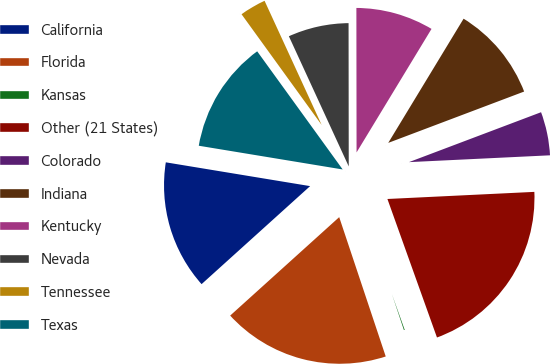Convert chart to OTSL. <chart><loc_0><loc_0><loc_500><loc_500><pie_chart><fcel>California<fcel>Florida<fcel>Kansas<fcel>Other (21 States)<fcel>Colorado<fcel>Indiana<fcel>Kentucky<fcel>Nevada<fcel>Tennessee<fcel>Texas<nl><fcel>14.29%<fcel>18.44%<fcel>0.34%<fcel>20.3%<fcel>4.98%<fcel>10.57%<fcel>8.7%<fcel>6.84%<fcel>3.11%<fcel>12.43%<nl></chart> 